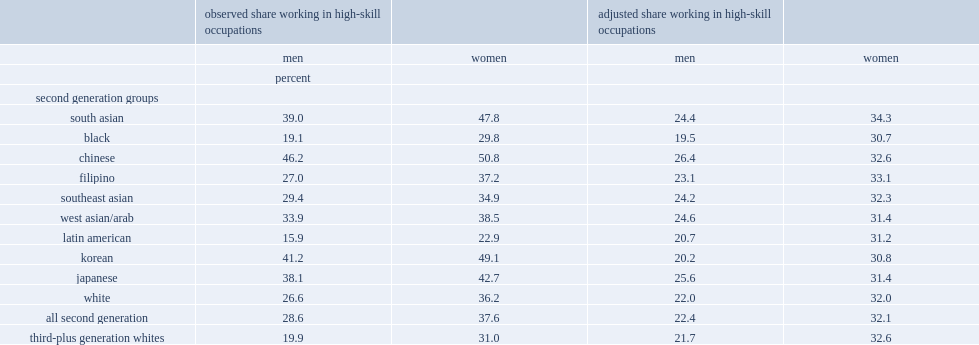Could you help me parse every detail presented in this table? {'header': ['', 'observed share working in high-skill occupations', '', 'adjusted share working in high-skill occupations', ''], 'rows': [['', 'men', 'women', 'men', 'women'], ['', 'percent', '', '', ''], ['second generation groups', '', '', '', ''], ['south asian', '39.0', '47.8', '24.4', '34.3'], ['black', '19.1', '29.8', '19.5', '30.7'], ['chinese', '46.2', '50.8', '26.4', '32.6'], ['filipino', '27.0', '37.2', '23.1', '33.1'], ['southeast asian', '29.4', '34.9', '24.2', '32.3'], ['west asian/arab', '33.9', '38.5', '24.6', '31.4'], ['latin american', '15.9', '22.9', '20.7', '31.2'], ['korean', '41.2', '49.1', '20.2', '30.8'], ['japanese', '38.1', '42.7', '25.6', '31.4'], ['white', '26.6', '36.2', '22.0', '32.0'], ['all second generation', '28.6', '37.6', '22.4', '32.1'], ['third-plus generation whites', '19.9', '31.0', '21.7', '32.6']]} List all the second generation groups that have high-skill occupations proportion larger than 40% in ovserved share. Chinese korean japanese south asian. What was the percent of men among third-plus generation whites that worked in high-skill occupations, according to ovserved share? 19.9. What was the percent of women among third-plus generation whites that worked in high-skill occupations, according to ovserved share? 31. Which second generations are more likely to work in high-skill occupations than third-plus generation? Filipino southeast asian west asian/arab white. Which second generations are similar or smaller than third-plus generation whites? Black latin american. 